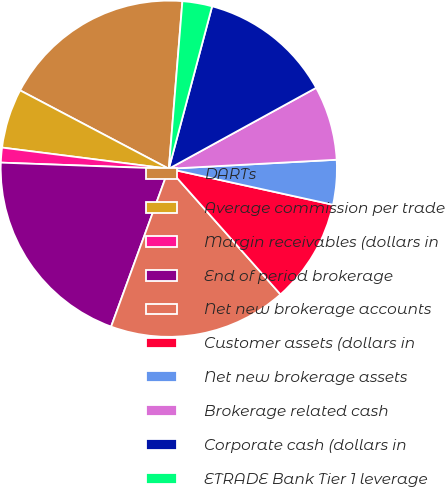<chart> <loc_0><loc_0><loc_500><loc_500><pie_chart><fcel>DARTs<fcel>Average commission per trade<fcel>Margin receivables (dollars in<fcel>End of period brokerage<fcel>Net new brokerage accounts<fcel>Customer assets (dollars in<fcel>Net new brokerage assets<fcel>Brokerage related cash<fcel>Corporate cash (dollars in<fcel>ETRADE Bank Tier 1 leverage<nl><fcel>18.57%<fcel>5.71%<fcel>1.43%<fcel>20.0%<fcel>17.14%<fcel>10.0%<fcel>4.29%<fcel>7.14%<fcel>12.86%<fcel>2.86%<nl></chart> 